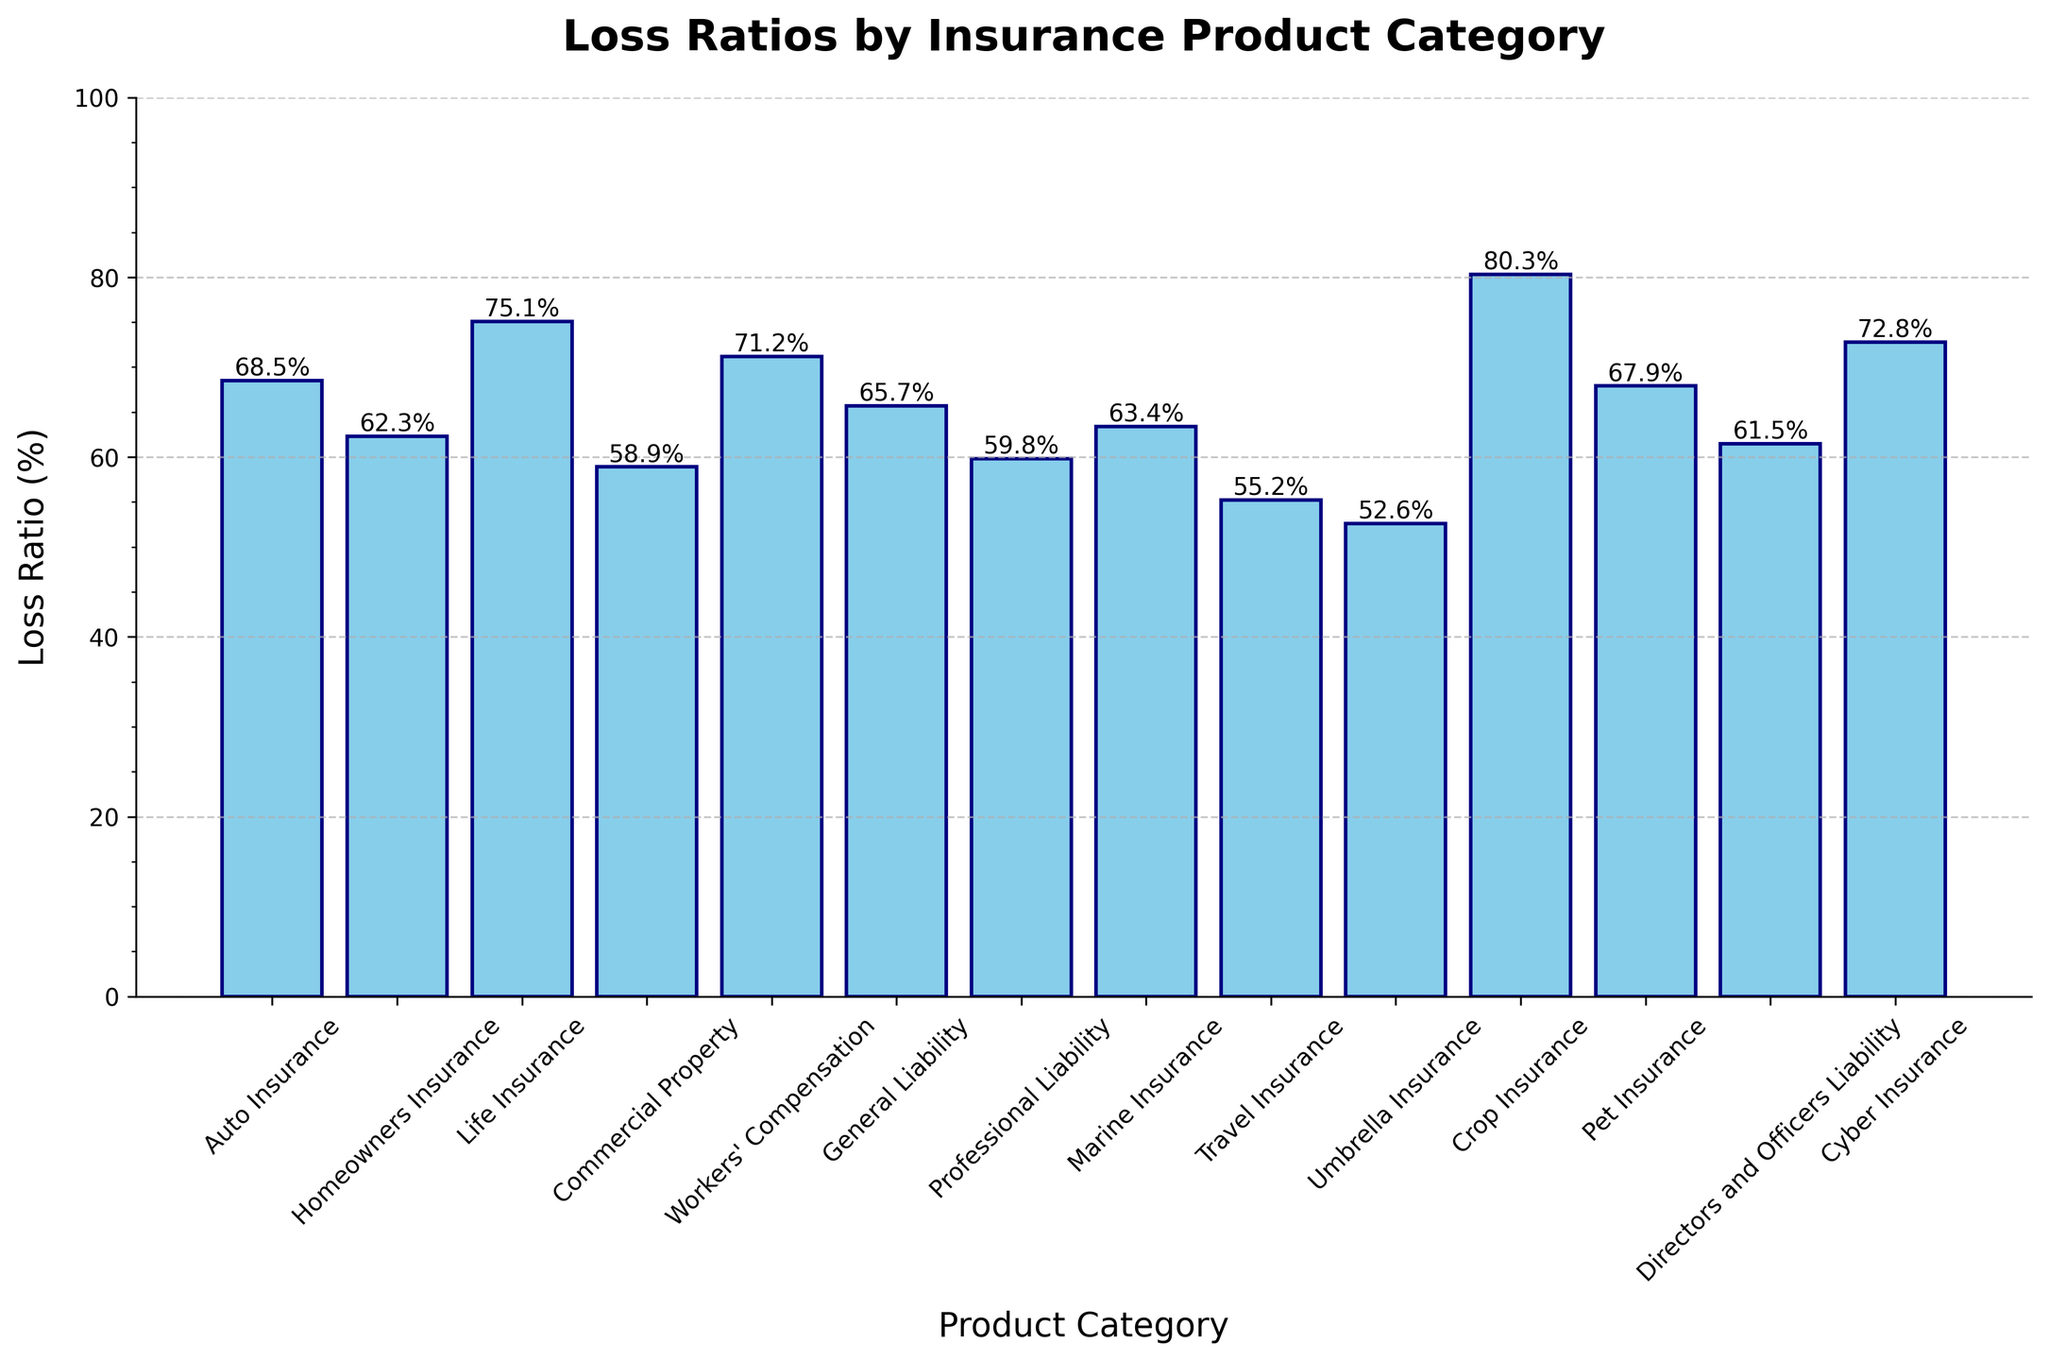Which product category has the highest loss ratio? The highest bar in the chart represents the product category with the highest loss ratio. In this case, it is "Crop Insurance" with a loss ratio of 80.3%.
Answer: Crop Insurance Which product category has the lowest loss ratio? The shortest bar in the chart represents the product category with the lowest loss ratio. In this case, it is "Umbrella Insurance" with a loss ratio of 52.6%.
Answer: Umbrella Insurance Which two product categories have loss ratios closest to each other? By inspecting the bars and their heights, "Homeowners Insurance" (62.3%) and "Marine Insurance" (63.4%) have the closest loss ratios. The difference is 1.1%.
Answer: Homeowners Insurance and Marine Insurance What is the average loss ratio of Auto Insurance, Homeowners Insurance, and Life Insurance? Sum the loss ratios of the three categories (68.5 + 62.3 + 75.1) and then divide by 3 to get the average: (68.5 + 62.3 + 75.1) / 3 = 68.63.
Answer: 68.63% How many product categories have loss ratios over 70%? Count the bars with heights exceeding the 70% mark. Crop Insurance (80.3%), Life Insurance (75.1%), Workers' Compensation (71.2%), and Cyber Insurance (72.8%). There are 4 categories.
Answer: 4 Which product category has the second-highest loss ratio? The second tallest bar in the chart represents the product category with the second-highest loss ratio. After Crop Insurance (80.3%), the next highest is "Life Insurance" with 75.1%.
Answer: Life Insurance Are there more product categories with loss ratios above or below 65%? Count the bars above 65% and below 65%. There are 7 categories above 65% and 7 categories below 65%.
Answer: Equal (7 above, 7 below) What is the difference in loss ratio between General Liability and Professional Liability? Subtract the loss ratio of Professional Liability (59.8%) from General Liability (65.7%): 65.7 - 59.8 = 5.9%.
Answer: 5.9% What is the total loss ratio for Commercial Property, Workers' Compensation, and Travel Insurance? Sum the loss ratios of the three categories: 58.9 + 71.2 + 55.2 = 185.3%.
Answer: 185.3% Which product categories fall within a loss ratio range of 60% to 70%? Identify the bars whose heights fall between 60% and 70%. These categories are: Auto Insurance (68.5%), Homeowners Insurance (62.3%), General Liability (65.7%), Marine Insurance (63.4%), and Directors and Officers Liability (61.5%).
Answer: Auto Insurance, Homeowners Insurance, General Liability, Marine Insurance, and Directors and Officers Liability 